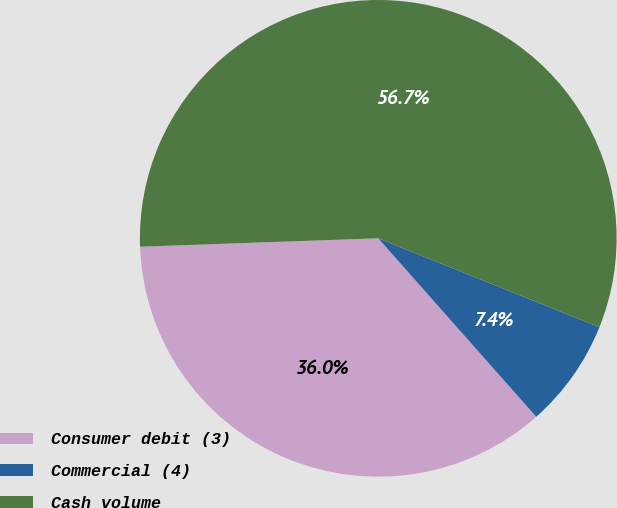Convert chart. <chart><loc_0><loc_0><loc_500><loc_500><pie_chart><fcel>Consumer debit (3)<fcel>Commercial (4)<fcel>Cash volume<nl><fcel>35.97%<fcel>7.38%<fcel>56.65%<nl></chart> 